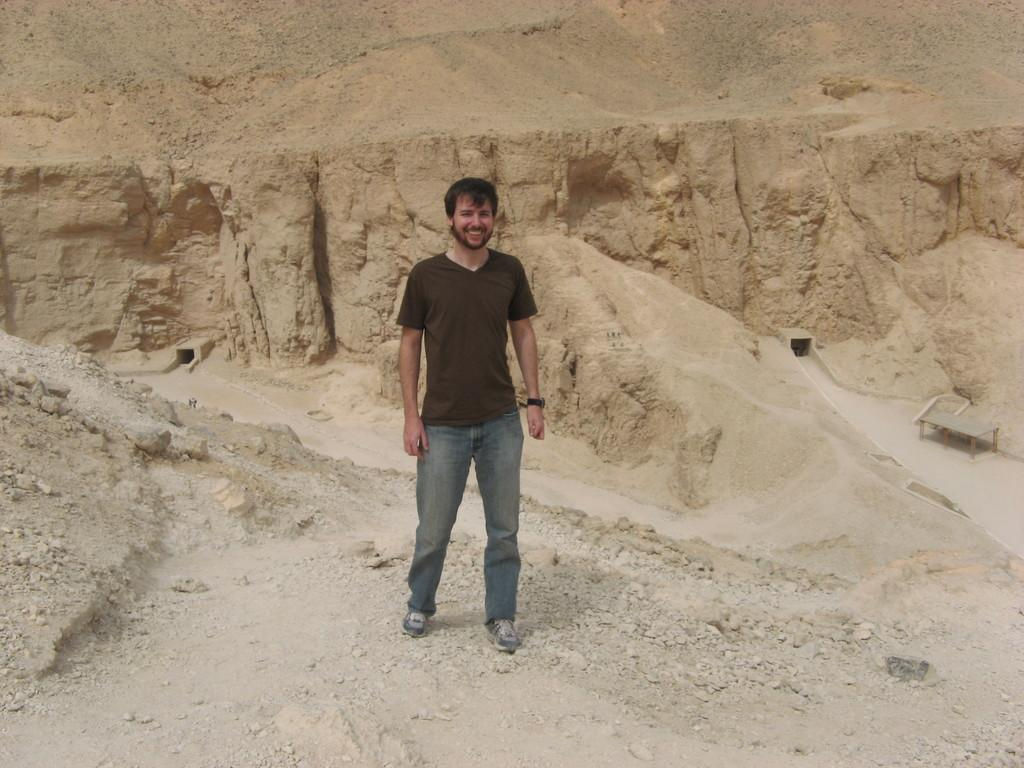What is the main subject of the image? There is a person standing in the image. Where is the person standing? The person is standing on the ground. What can be seen in the background of the image? There is a mountain in the background of the image. Can you describe the time of day when the image was likely taken? The image was likely taken during the day. What type of corn is growing on the mountain in the image? There is no corn visible in the image, and the mountain is in the background. 